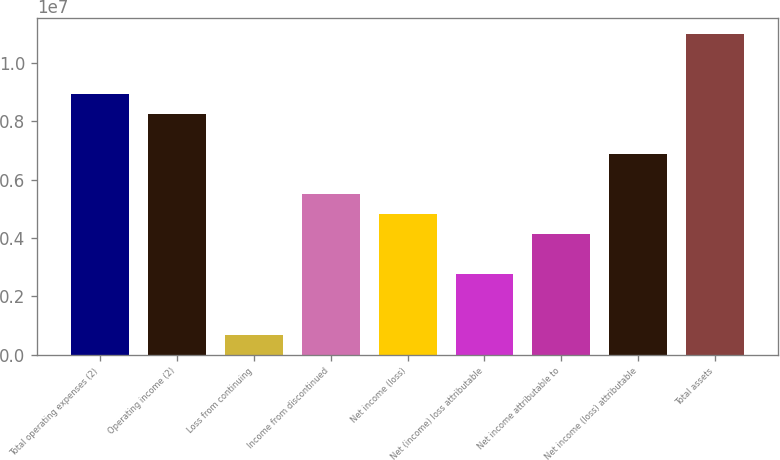<chart> <loc_0><loc_0><loc_500><loc_500><bar_chart><fcel>Total operating expenses (2)<fcel>Operating income (2)<fcel>Loss from continuing<fcel>Income from discontinued<fcel>Net income (loss)<fcel>Net (income) loss attributable<fcel>Net income attributable to<fcel>Net income (loss) attributable<fcel>Total assets<nl><fcel>8.93342e+06<fcel>8.24623e+06<fcel>687187<fcel>5.49749e+06<fcel>4.8103e+06<fcel>2.74875e+06<fcel>4.12312e+06<fcel>6.87186e+06<fcel>1.0995e+07<nl></chart> 